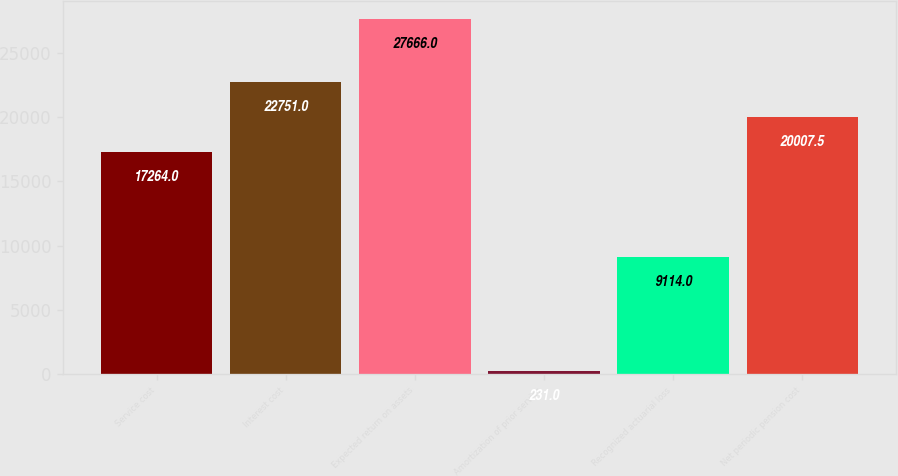<chart> <loc_0><loc_0><loc_500><loc_500><bar_chart><fcel>Service cost<fcel>Interest cost<fcel>Expected return on assets<fcel>Amortization of prior service<fcel>Recognized actuarial loss<fcel>Net periodic pension cost<nl><fcel>17264<fcel>22751<fcel>27666<fcel>231<fcel>9114<fcel>20007.5<nl></chart> 